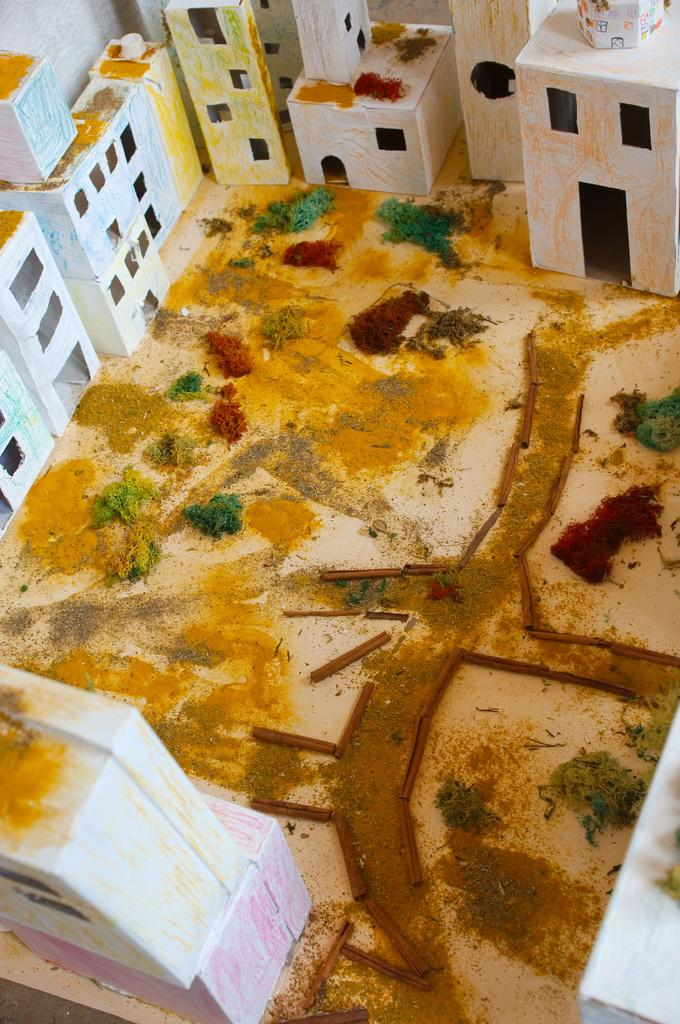What type of structures can be seen in the image? There are buildings in the image. What else is present in the image besides the buildings? There is a road and trees visible in the image. What can be seen beneath the buildings and trees? The ground is visible in the image. What type of debt is being discussed in the image? There is no mention of debt in the image; it features buildings, a road, trees, and the ground. Can you see a badge on any of the buildings in the image? There is no badge visible on any of the buildings in the image. 